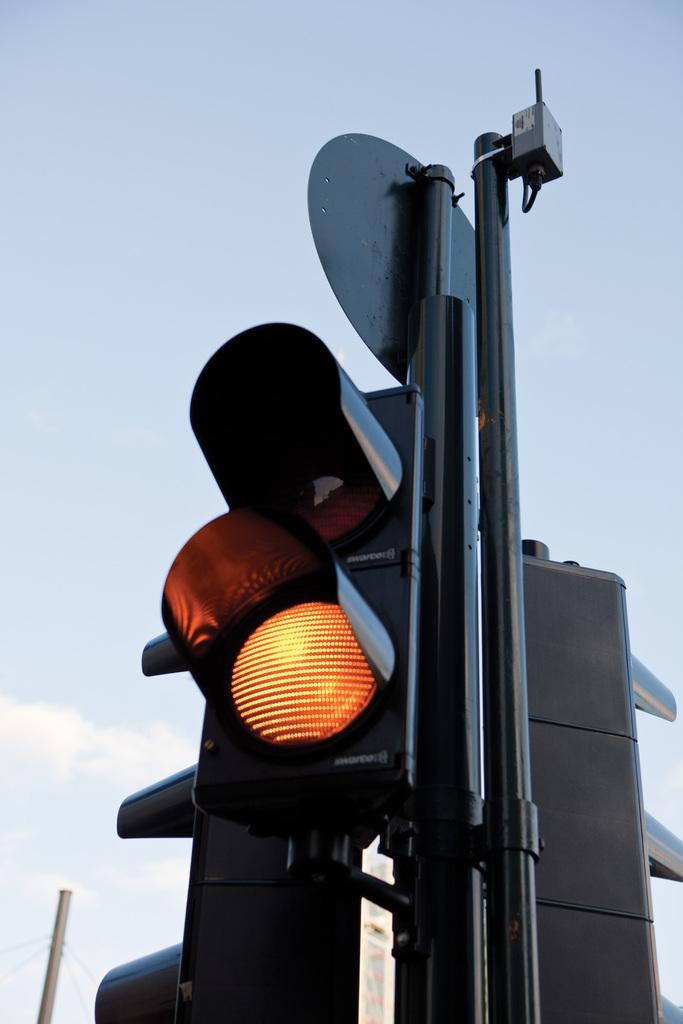How would you summarize this image in a sentence or two? There are poles with traffic signals. In the background there is sky. Also there is a pole in the background. 